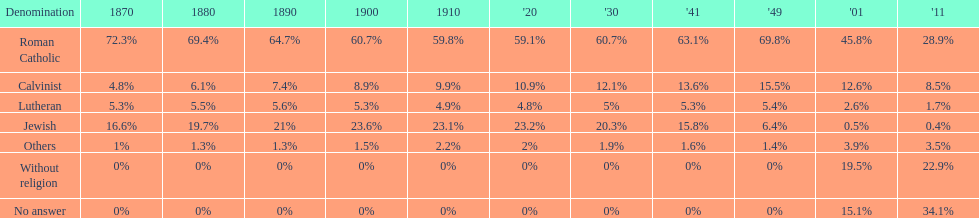What proportion of the population identified themselves as religious in the year 2011? 43%. 